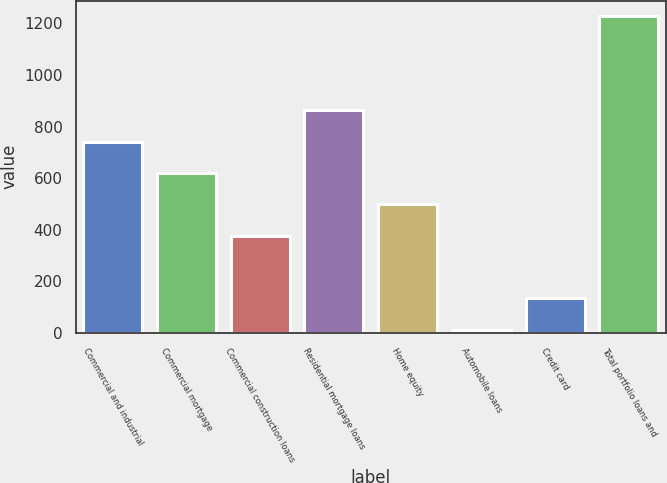Convert chart. <chart><loc_0><loc_0><loc_500><loc_500><bar_chart><fcel>Commercial and industrial<fcel>Commercial mortgage<fcel>Commercial construction loans<fcel>Residential mortgage loans<fcel>Home equity<fcel>Automobile loans<fcel>Credit card<fcel>Total portfolio loans and<nl><fcel>741<fcel>619.5<fcel>376.5<fcel>862.5<fcel>498<fcel>12<fcel>133.5<fcel>1227<nl></chart> 